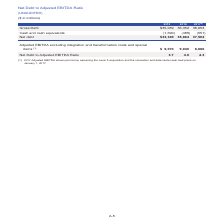According to Centurylink's financial document, What is the assumption for the 2017 adjusted EBITDA shown pro forma? the Level 3 acquisition and the colocation and data center sale took place on January 1, 2017.. The document states: "(1) 2017 Adjusted EBITDA shown pro forma, assuming the Level 3 acquisition and the colocation and data center sale took place on January 1, 2017...." Also, What is the gross debt in 2019? According to the financial document, $35,039 (in millions). The relevant text states: "Gross Debt $35,039 36,352 38,053..." Also, Which years does the table show the Net Debt to Adjusted EBITDA Ratio? The document contains multiple relevant values: 2019, 2018, 2017. From the document: "2019 2018 2017 (1) 2019 2018 2017 (1) 2019 2018 2017 (1)..." Also, can you calculate: What is the change in gross debt in 2019 from 2018? Based on the calculation: $35,039-$36,352, the result is -1313 (in millions). This is based on the information: "Gross Debt $35,039 36,352 38,053 Gross Debt $35,039 36,352 38,053..." The key data points involved are: 35,039, 36,352. Also, can you calculate: What is the total gross debt over the three years? Based on the calculation: $35,039+$36,352+$38,053, the result is 109444 (in millions). This is based on the information: "Gross Debt $35,039 36,352 38,053 Gross Debt $35,039 36,352 38,053 Gross Debt $35,039 36,352 38,053..." The key data points involved are: 35,039, 36,352, 38,053. Also, can you calculate: What is the percentage change in gross debt in 2019 from 2018? To answer this question, I need to perform calculations using the financial data. The calculation is: ($35,039-$36,352)/$36,352, which equals -3.61 (percentage). This is based on the information: "Gross Debt $35,039 36,352 38,053 Gross Debt $35,039 36,352 38,053..." The key data points involved are: 35,039, 36,352. 